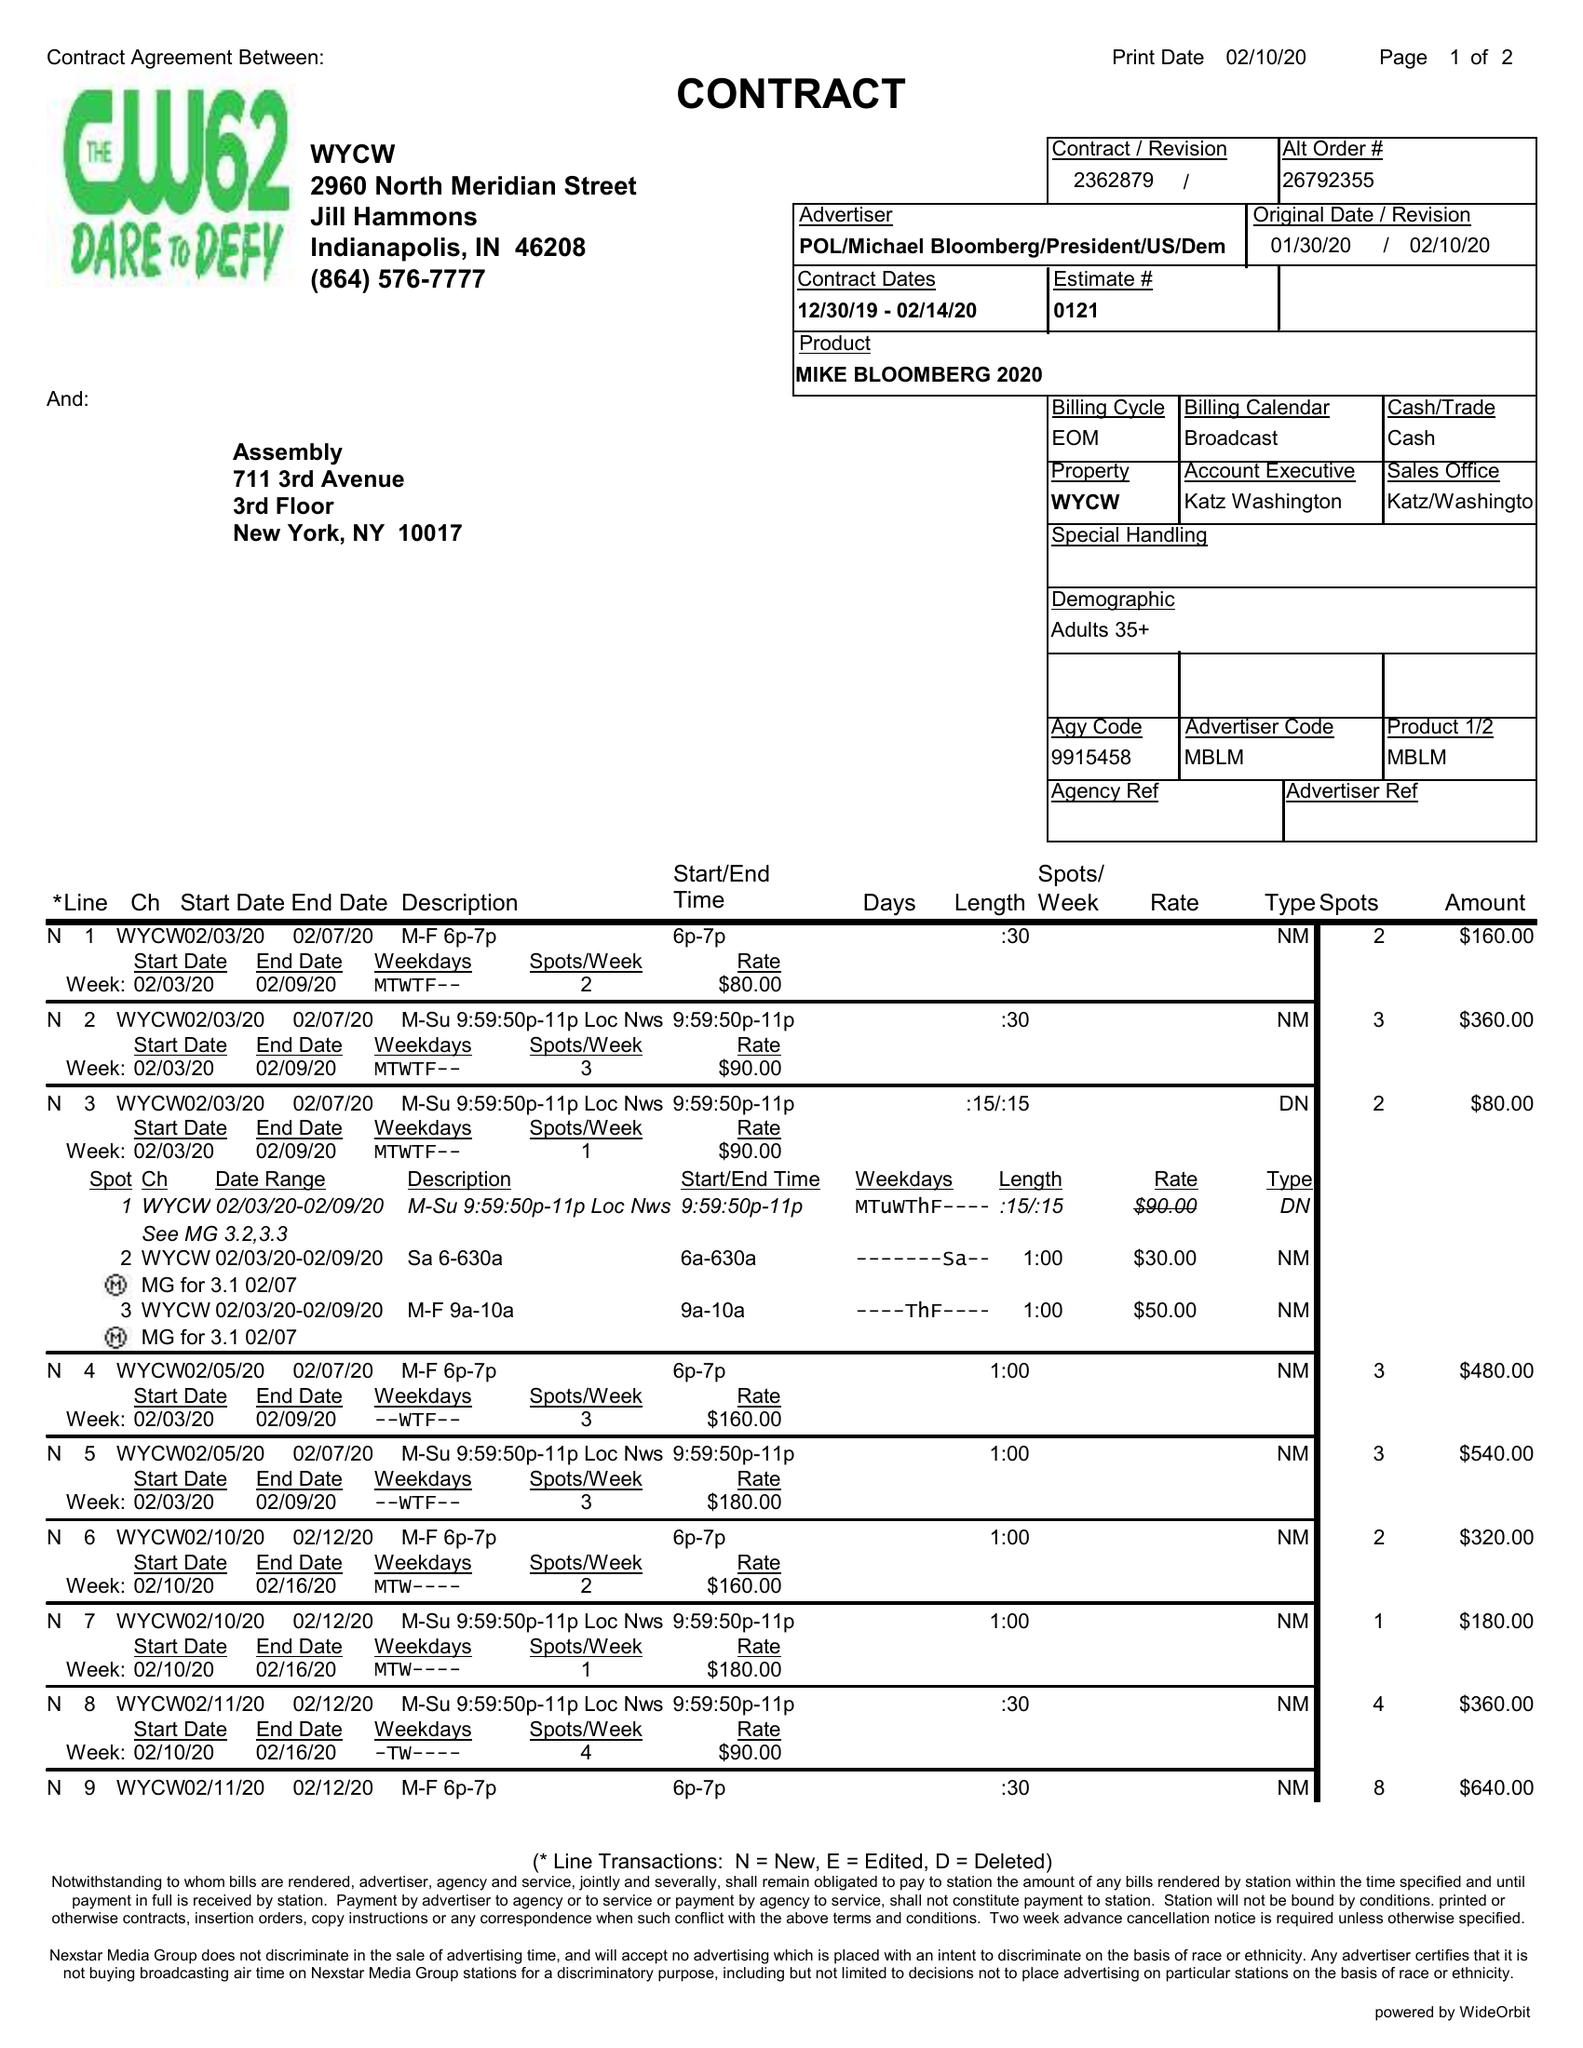What is the value for the advertiser?
Answer the question using a single word or phrase. POL/MICHAELBLOOMBERG/PRESIDENT/US/DEM 